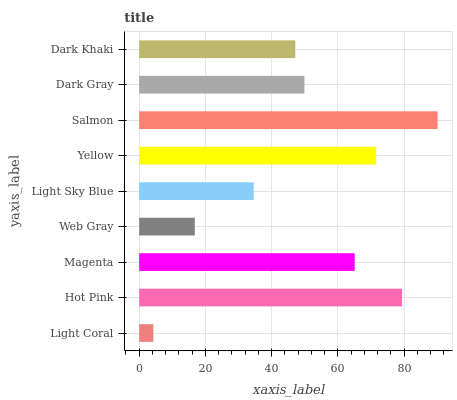Is Light Coral the minimum?
Answer yes or no. Yes. Is Salmon the maximum?
Answer yes or no. Yes. Is Hot Pink the minimum?
Answer yes or no. No. Is Hot Pink the maximum?
Answer yes or no. No. Is Hot Pink greater than Light Coral?
Answer yes or no. Yes. Is Light Coral less than Hot Pink?
Answer yes or no. Yes. Is Light Coral greater than Hot Pink?
Answer yes or no. No. Is Hot Pink less than Light Coral?
Answer yes or no. No. Is Dark Gray the high median?
Answer yes or no. Yes. Is Dark Gray the low median?
Answer yes or no. Yes. Is Dark Khaki the high median?
Answer yes or no. No. Is Light Sky Blue the low median?
Answer yes or no. No. 